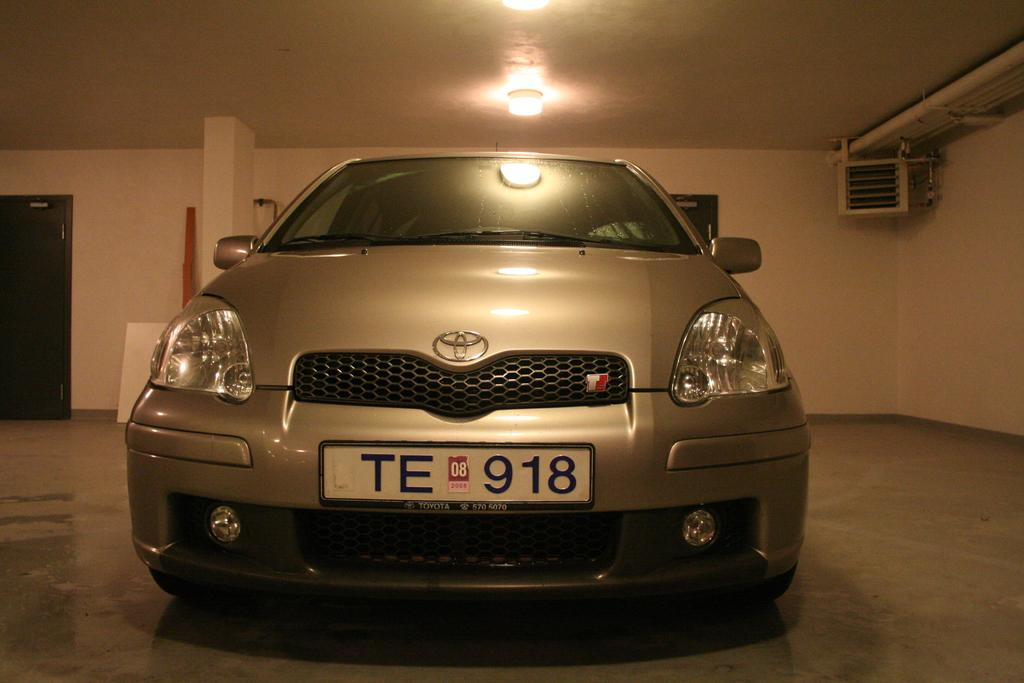What is the main object in the image? There is a car in the image. What else can be seen in the image besides the car? There is a light, a white color wall, and a door in the image. What songs are being played by the ornament in the image? There is no ornament present in the image, and therefore no songs can be played by it. 